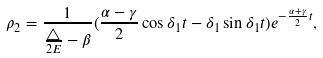Convert formula to latex. <formula><loc_0><loc_0><loc_500><loc_500>\rho _ { 2 } = \frac { 1 } { \frac { \triangle } { 2 E } - \beta } ( \frac { \alpha - \gamma } { 2 } \cos \delta _ { 1 } t - \delta _ { 1 } \sin \delta _ { 1 } t ) e ^ { - \frac { \alpha + \gamma } { 2 } t } ,</formula> 